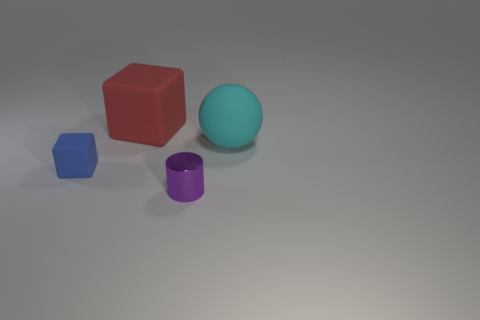Add 3 cyan matte blocks. How many objects exist? 7 Subtract 1 cubes. How many cubes are left? 1 Add 4 large red shiny blocks. How many large red shiny blocks exist? 4 Subtract all red blocks. How many blocks are left? 1 Subtract 0 blue cylinders. How many objects are left? 4 Subtract all cylinders. How many objects are left? 3 Subtract all blue blocks. Subtract all green cylinders. How many blocks are left? 1 Subtract all yellow cylinders. How many yellow balls are left? 0 Subtract all small purple shiny cylinders. Subtract all tiny purple metallic objects. How many objects are left? 2 Add 1 tiny cylinders. How many tiny cylinders are left? 2 